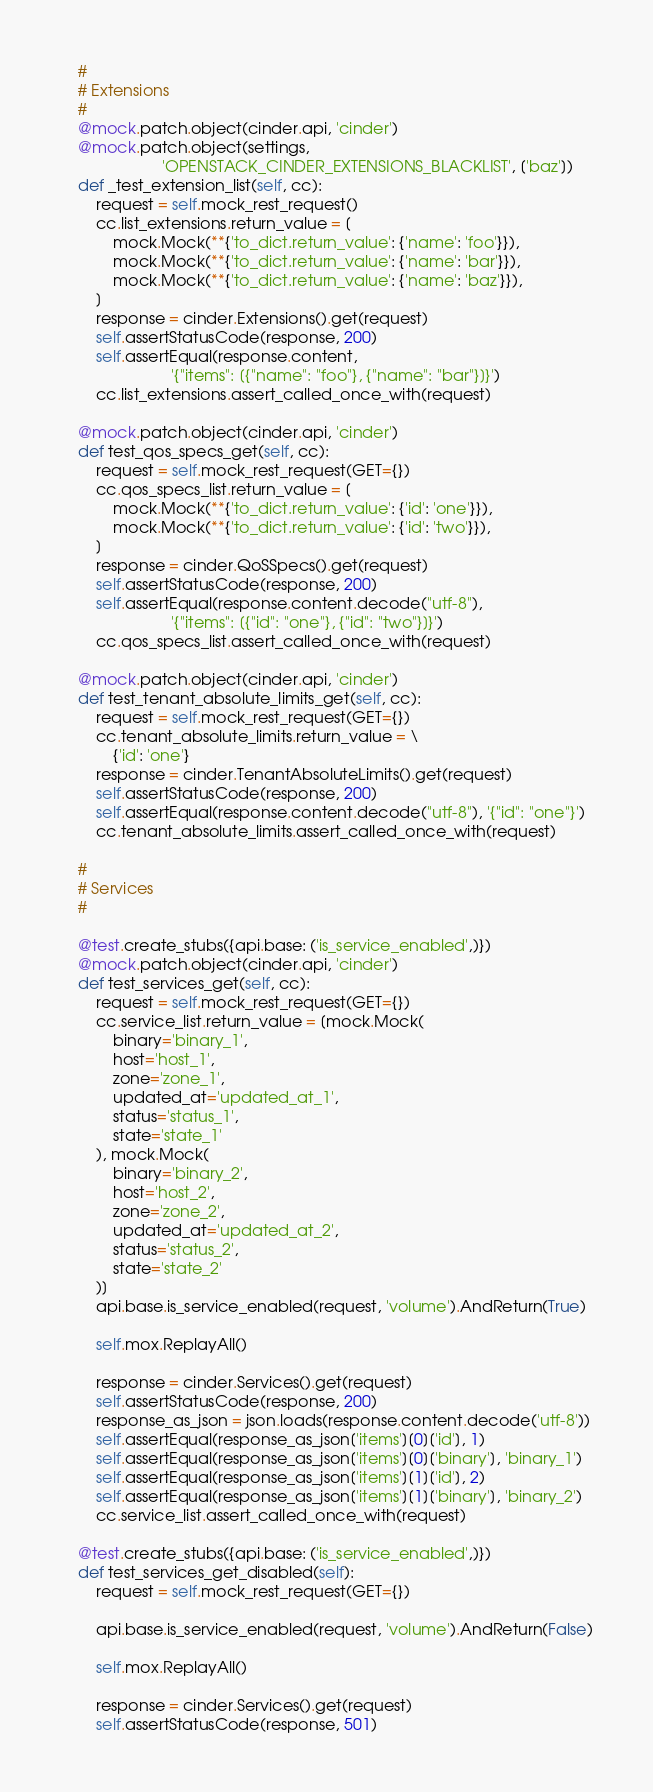Convert code to text. <code><loc_0><loc_0><loc_500><loc_500><_Python_>
    #
    # Extensions
    #
    @mock.patch.object(cinder.api, 'cinder')
    @mock.patch.object(settings,
                       'OPENSTACK_CINDER_EXTENSIONS_BLACKLIST', ['baz'])
    def _test_extension_list(self, cc):
        request = self.mock_rest_request()
        cc.list_extensions.return_value = [
            mock.Mock(**{'to_dict.return_value': {'name': 'foo'}}),
            mock.Mock(**{'to_dict.return_value': {'name': 'bar'}}),
            mock.Mock(**{'to_dict.return_value': {'name': 'baz'}}),
        ]
        response = cinder.Extensions().get(request)
        self.assertStatusCode(response, 200)
        self.assertEqual(response.content,
                         '{"items": [{"name": "foo"}, {"name": "bar"}]}')
        cc.list_extensions.assert_called_once_with(request)

    @mock.patch.object(cinder.api, 'cinder')
    def test_qos_specs_get(self, cc):
        request = self.mock_rest_request(GET={})
        cc.qos_specs_list.return_value = [
            mock.Mock(**{'to_dict.return_value': {'id': 'one'}}),
            mock.Mock(**{'to_dict.return_value': {'id': 'two'}}),
        ]
        response = cinder.QoSSpecs().get(request)
        self.assertStatusCode(response, 200)
        self.assertEqual(response.content.decode("utf-8"),
                         '{"items": [{"id": "one"}, {"id": "two"}]}')
        cc.qos_specs_list.assert_called_once_with(request)

    @mock.patch.object(cinder.api, 'cinder')
    def test_tenant_absolute_limits_get(self, cc):
        request = self.mock_rest_request(GET={})
        cc.tenant_absolute_limits.return_value = \
            {'id': 'one'}
        response = cinder.TenantAbsoluteLimits().get(request)
        self.assertStatusCode(response, 200)
        self.assertEqual(response.content.decode("utf-8"), '{"id": "one"}')
        cc.tenant_absolute_limits.assert_called_once_with(request)

    #
    # Services
    #

    @test.create_stubs({api.base: ('is_service_enabled',)})
    @mock.patch.object(cinder.api, 'cinder')
    def test_services_get(self, cc):
        request = self.mock_rest_request(GET={})
        cc.service_list.return_value = [mock.Mock(
            binary='binary_1',
            host='host_1',
            zone='zone_1',
            updated_at='updated_at_1',
            status='status_1',
            state='state_1'
        ), mock.Mock(
            binary='binary_2',
            host='host_2',
            zone='zone_2',
            updated_at='updated_at_2',
            status='status_2',
            state='state_2'
        )]
        api.base.is_service_enabled(request, 'volume').AndReturn(True)

        self.mox.ReplayAll()

        response = cinder.Services().get(request)
        self.assertStatusCode(response, 200)
        response_as_json = json.loads(response.content.decode('utf-8'))
        self.assertEqual(response_as_json['items'][0]['id'], 1)
        self.assertEqual(response_as_json['items'][0]['binary'], 'binary_1')
        self.assertEqual(response_as_json['items'][1]['id'], 2)
        self.assertEqual(response_as_json['items'][1]['binary'], 'binary_2')
        cc.service_list.assert_called_once_with(request)

    @test.create_stubs({api.base: ('is_service_enabled',)})
    def test_services_get_disabled(self):
        request = self.mock_rest_request(GET={})

        api.base.is_service_enabled(request, 'volume').AndReturn(False)

        self.mox.ReplayAll()

        response = cinder.Services().get(request)
        self.assertStatusCode(response, 501)
</code> 